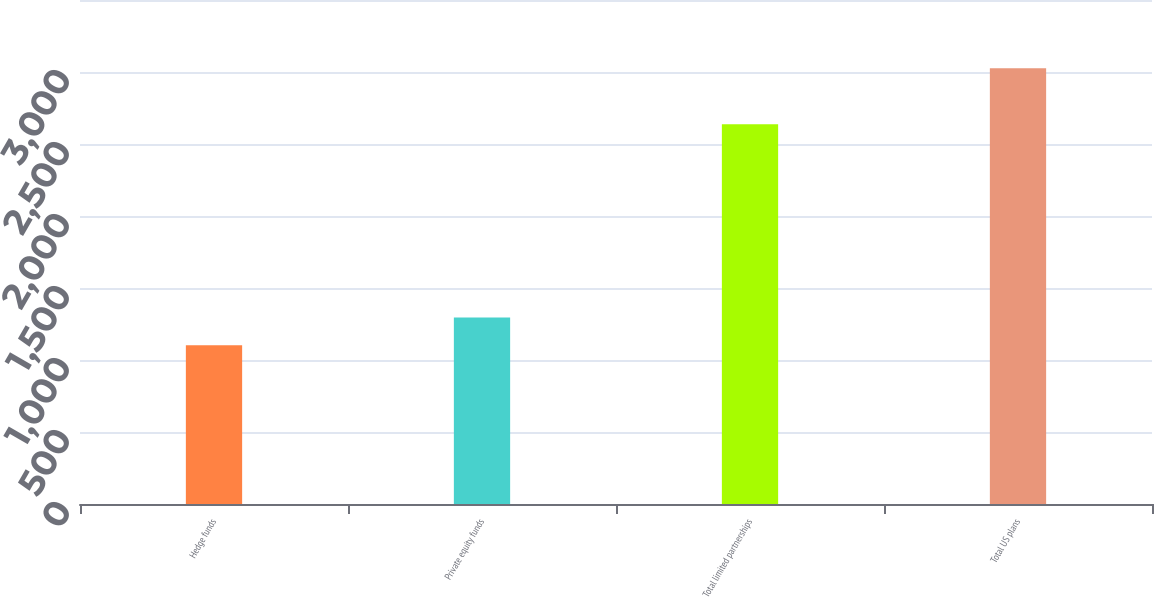<chart> <loc_0><loc_0><loc_500><loc_500><bar_chart><fcel>Hedge funds<fcel>Private equity funds<fcel>Total limited partnerships<fcel>Total US plans<nl><fcel>1102<fcel>1294.4<fcel>2638<fcel>3026<nl></chart> 